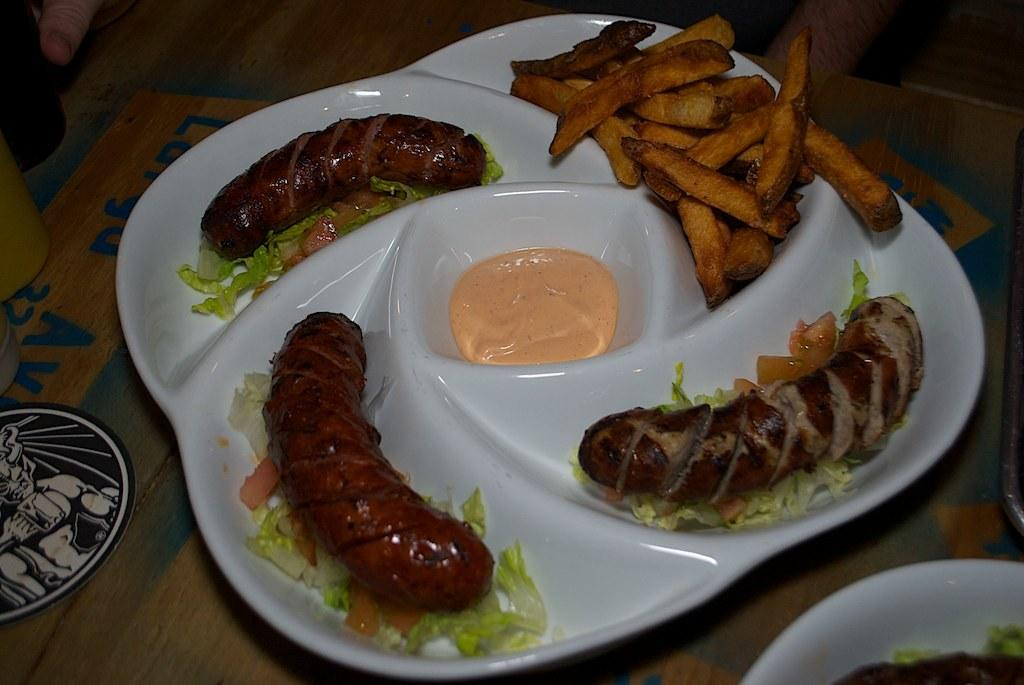What type of food can be seen in the image? There is food in the image, specifically fries. What color is the plate that holds the food? The plate is white. On what surface is the plate placed? The plate is placed on a brown color table. What is the name of the industry that produces the fries in the image? There is no information about the industry that produces the fries in the image. The focus is on the visual representation of the food, not its production or origin. 